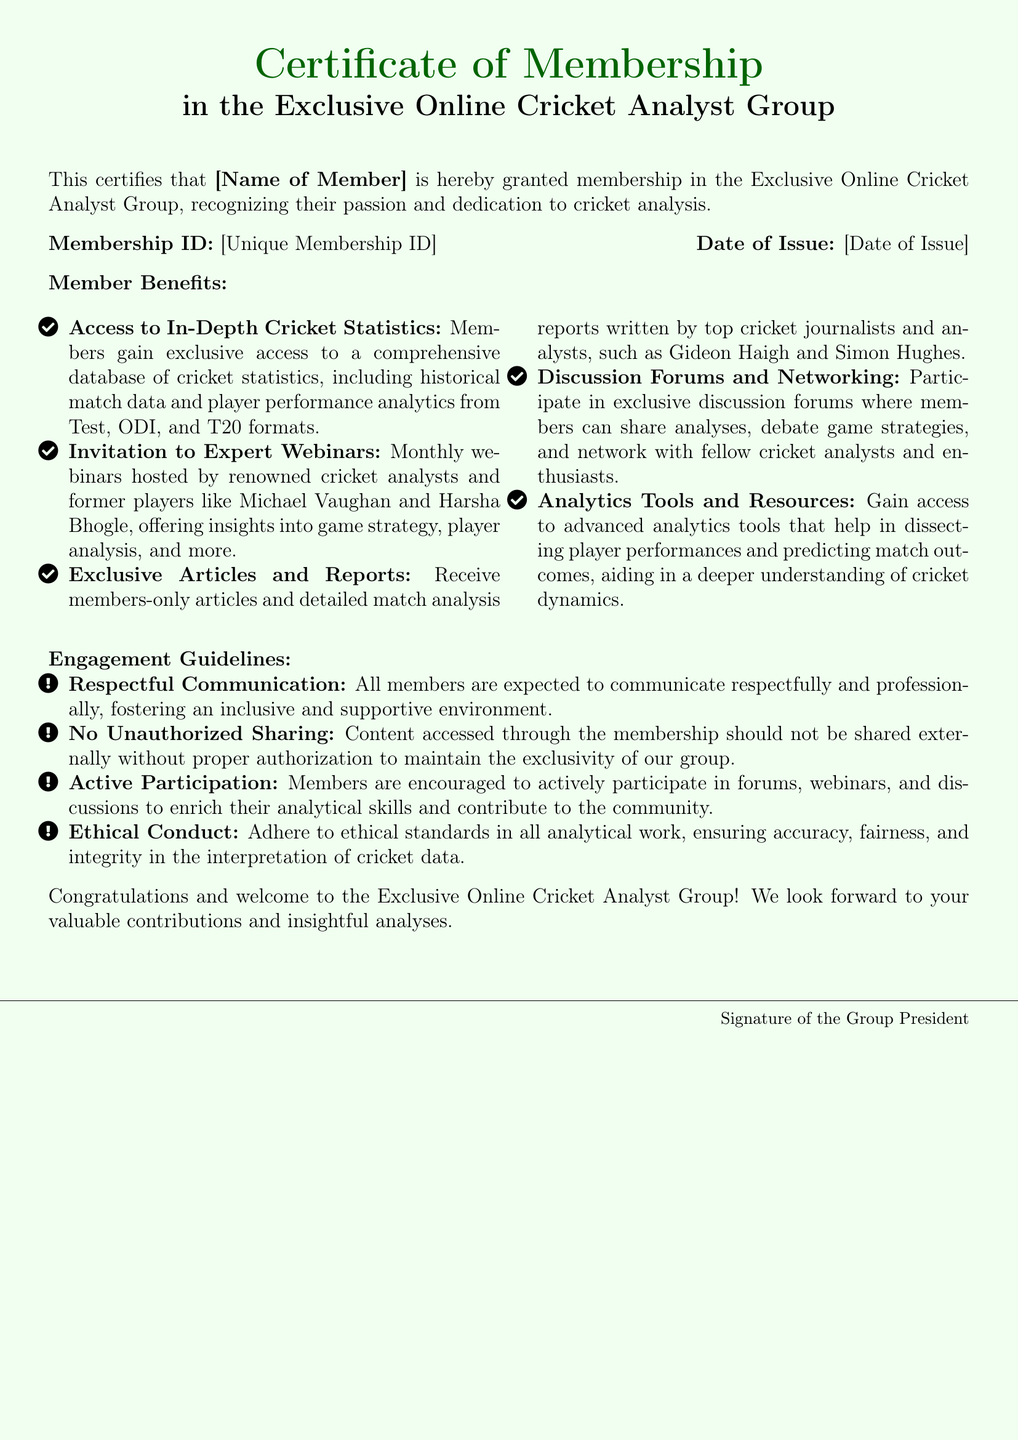What is the membership ID? The membership ID is a unique identifier given to each member, specified in the document as [Unique Membership ID].
Answer: [Unique Membership ID] Who issued the certificate? The certificate states it is issued by the Exclusive Online Cricket Analyst Group, but does not specify a name, only implying the president's role with a signature.
Answer: Group President What is the date of issue? The document includes a place for the date of issue, indicated as [Date of Issue], which is to be filled in specific details.
Answer: [Date of Issue] Name one benefit of membership. The document lists several benefits, such as access to in-depth cricket statistics, indicating the types of advantages provided to members.
Answer: Access to In-Depth Cricket Statistics What is one guideline for member engagement? The guidelines provided highlight expected conduct for members, showing how members should interact and participate within the group.
Answer: Respectful Communication What type of events do members get invited to? The document specifically mentions that members have access to monthly webinars featuring expert speakers.
Answer: Expert Webinars How many key benefits are listed in the document? Counting the items listed under member benefits reveals the total number of benefits provided to members.
Answer: Five What color scheme is used in the document? The document's color scheme describes the background and text colors, highlighting that cricket green and light green are the primary colors used.
Answer: Cricket green and light green What is the main purpose of this certificate? The certificate serves to officially recognize and celebrate the recipient's membership in a cricket analyst group, showcasing their involvement.
Answer: Membership recognition 